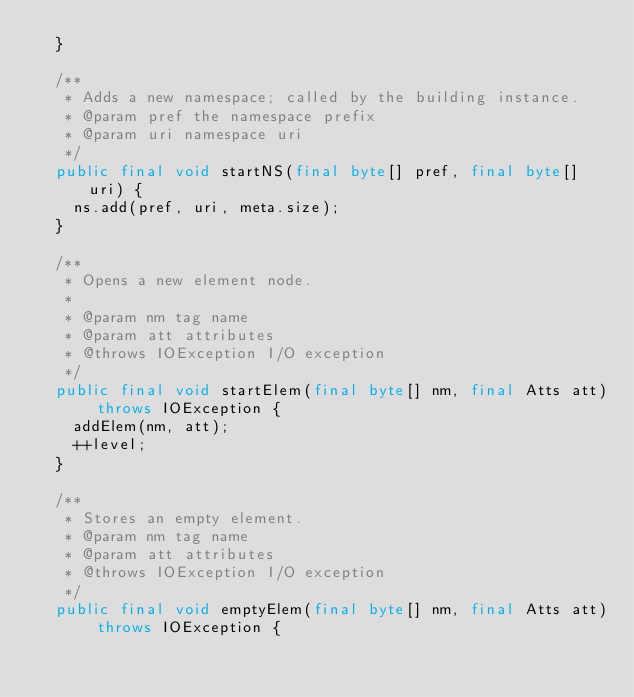Convert code to text. <code><loc_0><loc_0><loc_500><loc_500><_Java_>  }

  /**
   * Adds a new namespace; called by the building instance.
   * @param pref the namespace prefix
   * @param uri namespace uri
   */
  public final void startNS(final byte[] pref, final byte[] uri) {
    ns.add(pref, uri, meta.size);
  }

  /**
   * Opens a new element node.
   *
   * @param nm tag name
   * @param att attributes
   * @throws IOException I/O exception
   */
  public final void startElem(final byte[] nm, final Atts att) throws IOException {
    addElem(nm, att);
    ++level;
  }

  /**
   * Stores an empty element.
   * @param nm tag name
   * @param att attributes
   * @throws IOException I/O exception
   */
  public final void emptyElem(final byte[] nm, final Atts att) throws IOException {</code> 